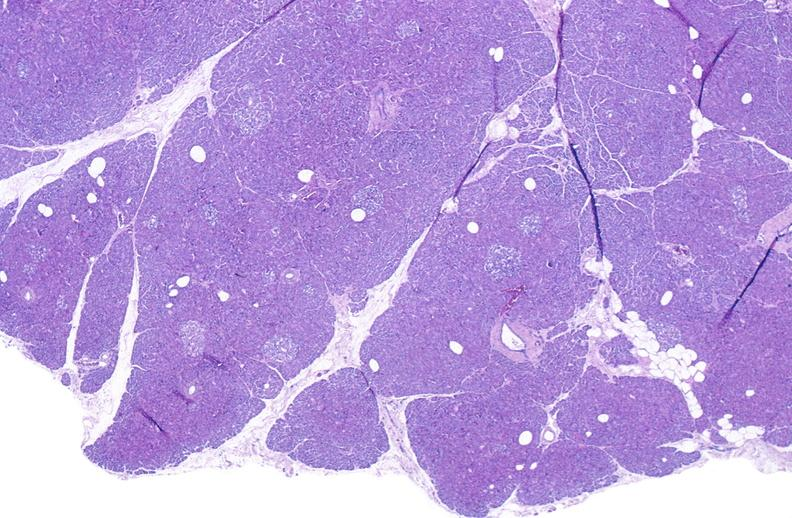does this image show normal pancreas?
Answer the question using a single word or phrase. Yes 